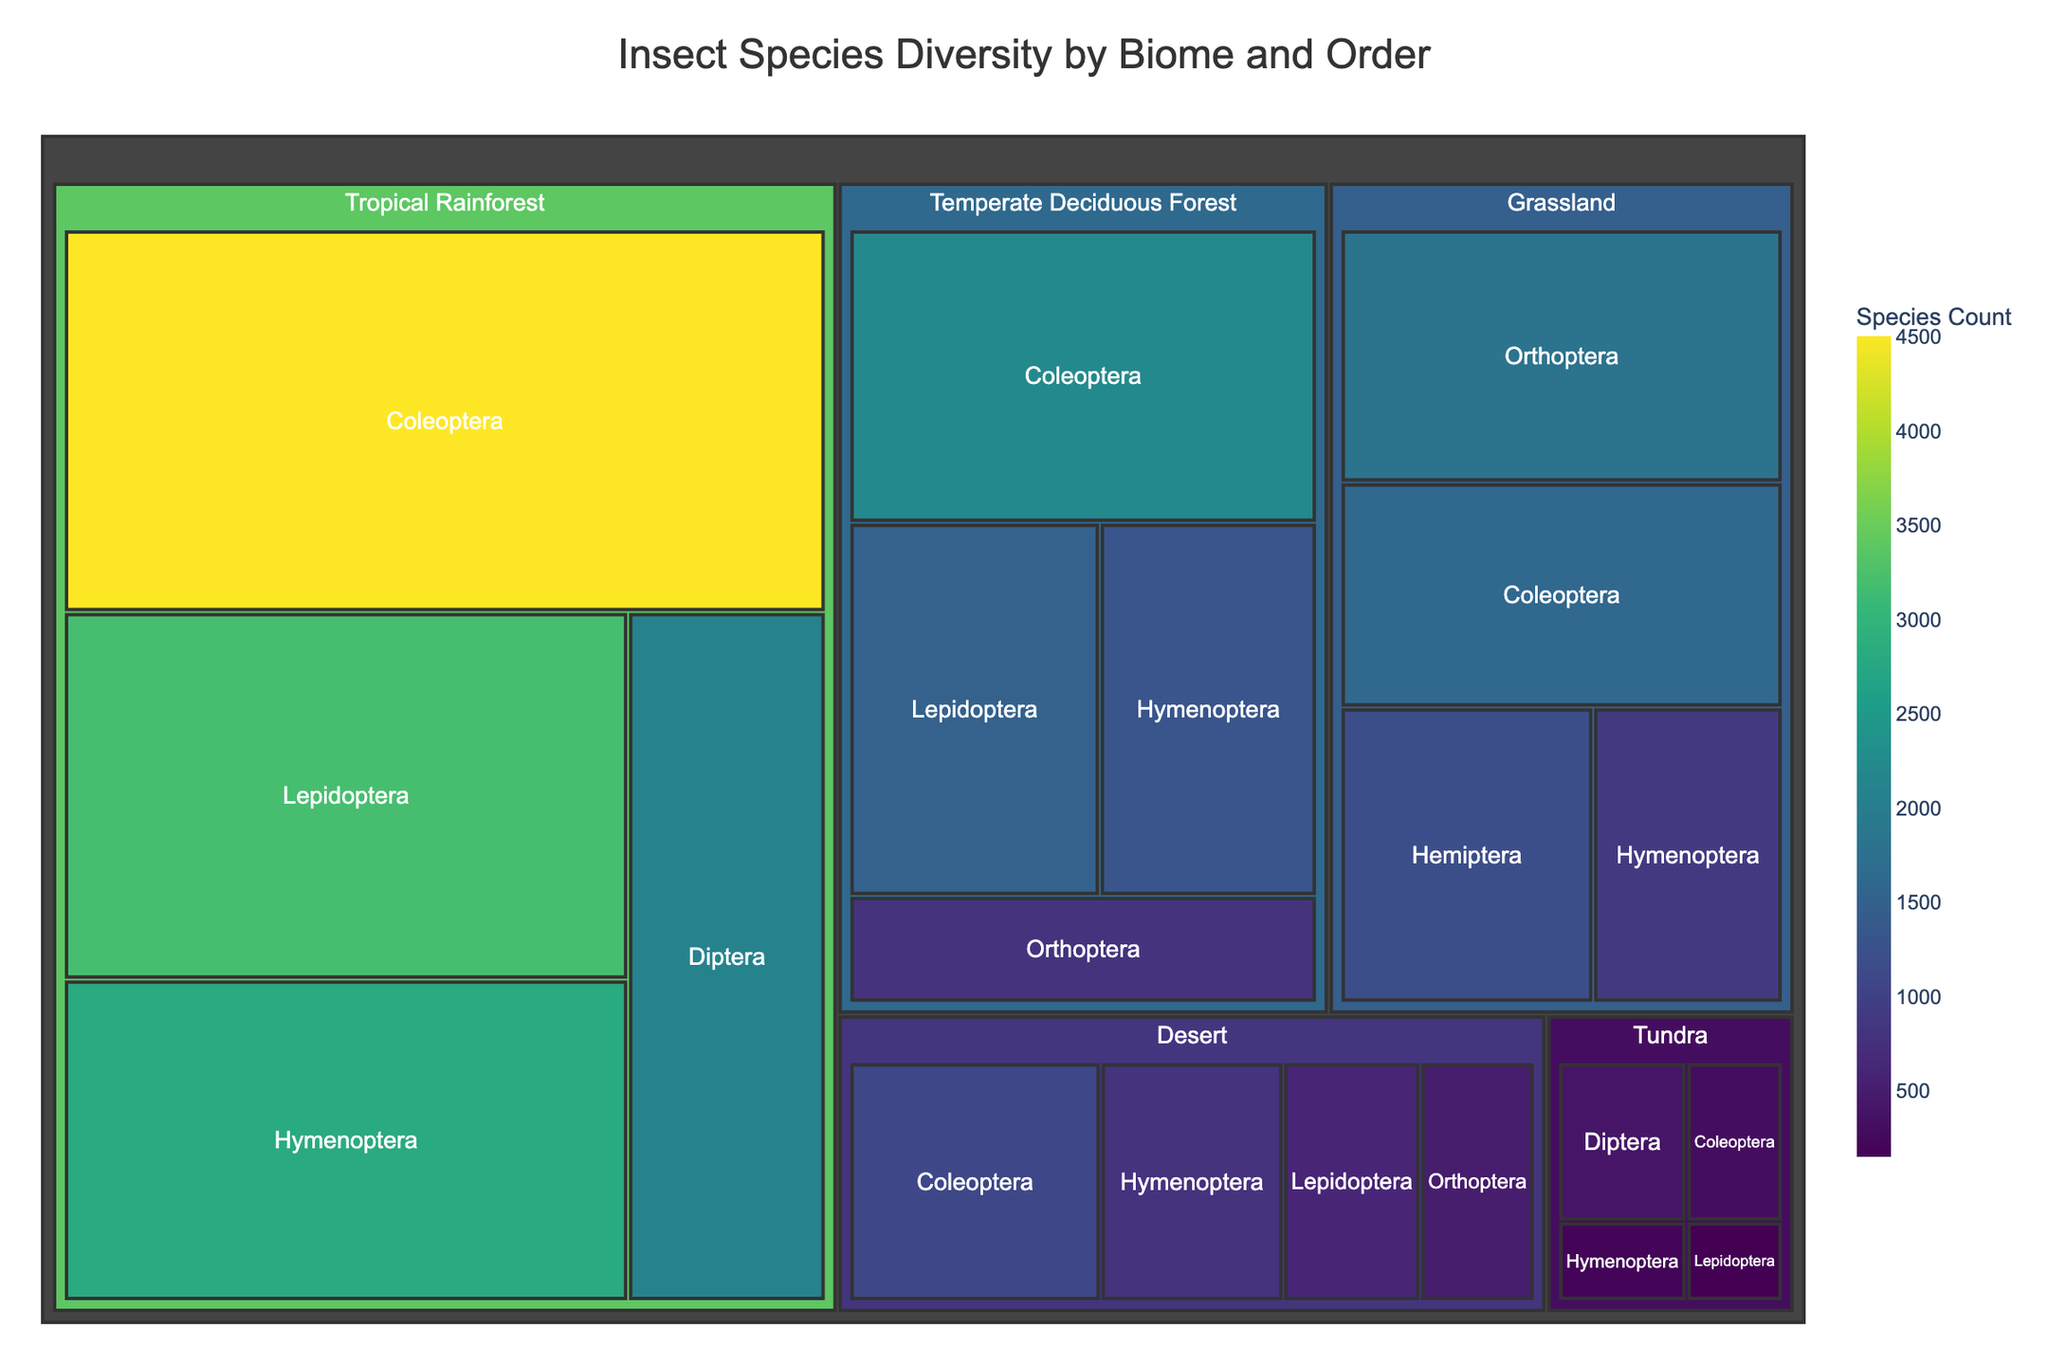What biome has the highest insect species count? By looking at the colored regions on the treemap, we see that the tropical rainforest biome has the largest sections, indicating the highest species count.
Answer: Tropical Rainforest Which insect order has the highest species count in the tropical rainforest biome? In the tropical rainforest section, the color and size of the 'Coleoptera' order's region is the largest, indicating it has the highest species count within the biome.
Answer: Coleoptera How many more species are there in the Coleoptera order compared to the Hymenoptera order in the temperate deciduous forest biome? In the temperate deciduous forest section, Coleoptera has 2200 species, and Hymenoptera has 1300 species. The difference is 2200 - 1300 = 900.
Answer: 900 Which insect order is most diverse in the tundra biome? In the tundra section, the largest and most prominent area belongs to the 'Diptera' order, indicating it is the most diverse order in that biome.
Answer: Diptera How much larger is the species count of Coleoptera in grasslands compared to that in deserts? In grasslands, Coleoptera has 1600 species, and in deserts, it has 1100 species. The difference is 1600 - 1100 = 500.
Answer: 500 What is the sum of species counts in the Orthoptera order across all biomes? Adding the species counts of Orthoptera in Tropical Rainforest (0), Temperate Deciduous Forest (800), Grassland (1800), and Desert (500) gives 0 + 800 + 1800 + 500 = 3100.
Answer: 3100 Which biome has the lowest total insect species count? By comparing the overall area size of biome sections, the tundra biome is the smallest, indicating the lowest total species count.
Answer: Tundra Which two orders have the most similar species counts in deserts? In the desert section, Hymenoptera has 800 species and Coleoptera has 1100 species. The next closest count to Hymenoptera is Orthoptera with 500, so Hymenoptera and Lepidoptera have the most similar species counts.
Answer: Hymenoptera and Lepidoptera How many insect orders are present in the tropical rainforest biome? Looking at the distinct regions within the tropical rainforest section, there are four orders: Coleoptera, Lepidoptera, Hymenoptera, and Diptera.
Answer: 4 What is the difference between the species count of Diptera in tundra and tropical rainforest? Diptera in tundra has 400 species, and Diptera in tropical rainforest has 2100 species. The difference is 2100 - 400 = 1700.
Answer: 1700 